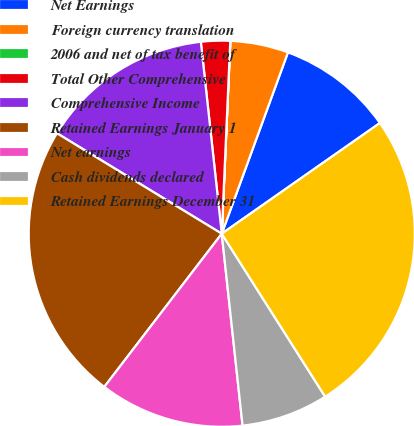<chart> <loc_0><loc_0><loc_500><loc_500><pie_chart><fcel>Net Earnings<fcel>Foreign currency translation<fcel>2006 and net of tax benefit of<fcel>Total Other Comprehensive<fcel>Comprehensive Income<fcel>Retained Earnings January 1<fcel>Net earnings<fcel>Cash dividends declared<fcel>Retained Earnings December 31<nl><fcel>9.71%<fcel>4.86%<fcel>0.01%<fcel>2.43%<fcel>14.56%<fcel>23.3%<fcel>12.13%<fcel>7.28%<fcel>25.72%<nl></chart> 